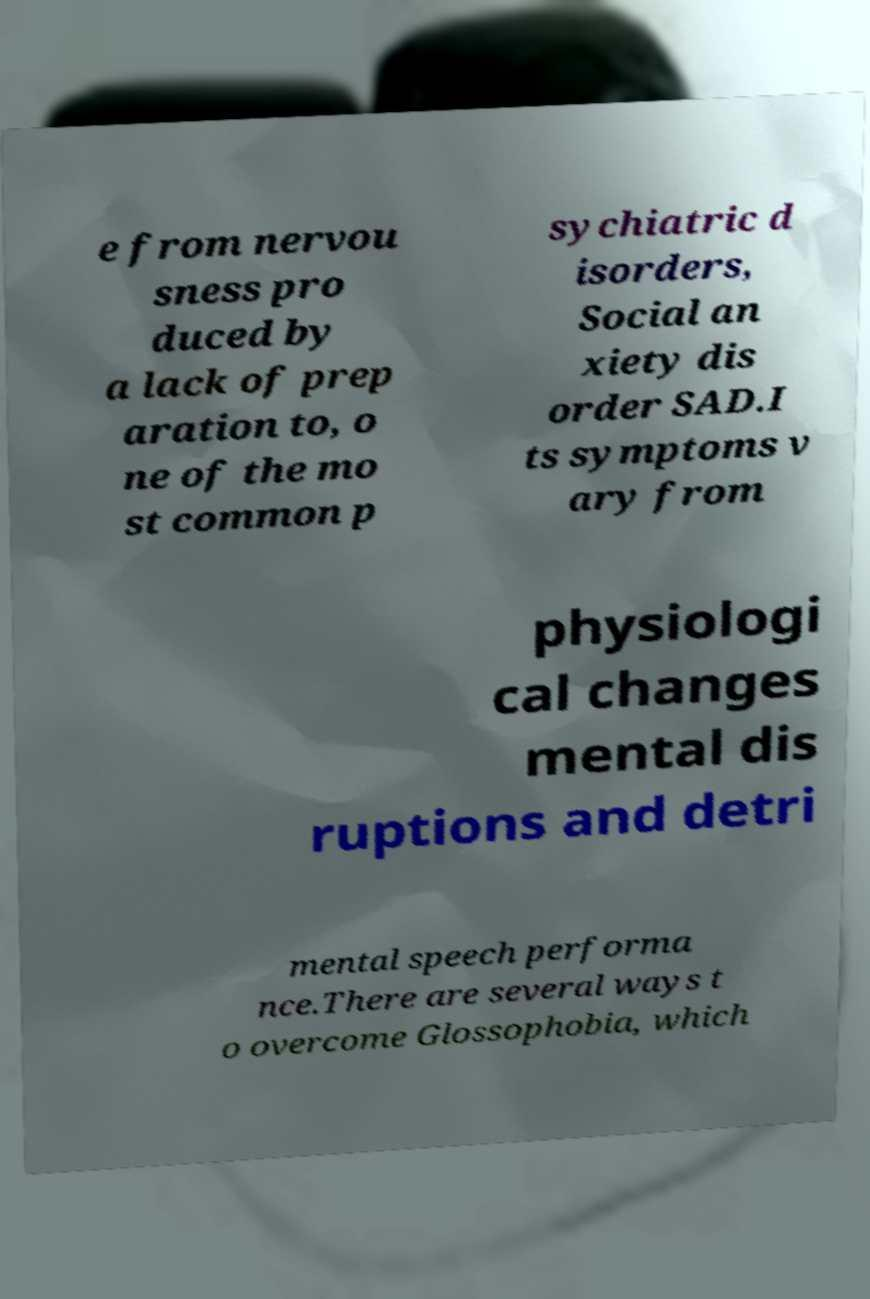What messages or text are displayed in this image? I need them in a readable, typed format. e from nervou sness pro duced by a lack of prep aration to, o ne of the mo st common p sychiatric d isorders, Social an xiety dis order SAD.I ts symptoms v ary from physiologi cal changes mental dis ruptions and detri mental speech performa nce.There are several ways t o overcome Glossophobia, which 